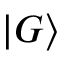<formula> <loc_0><loc_0><loc_500><loc_500>| G \rangle</formula> 